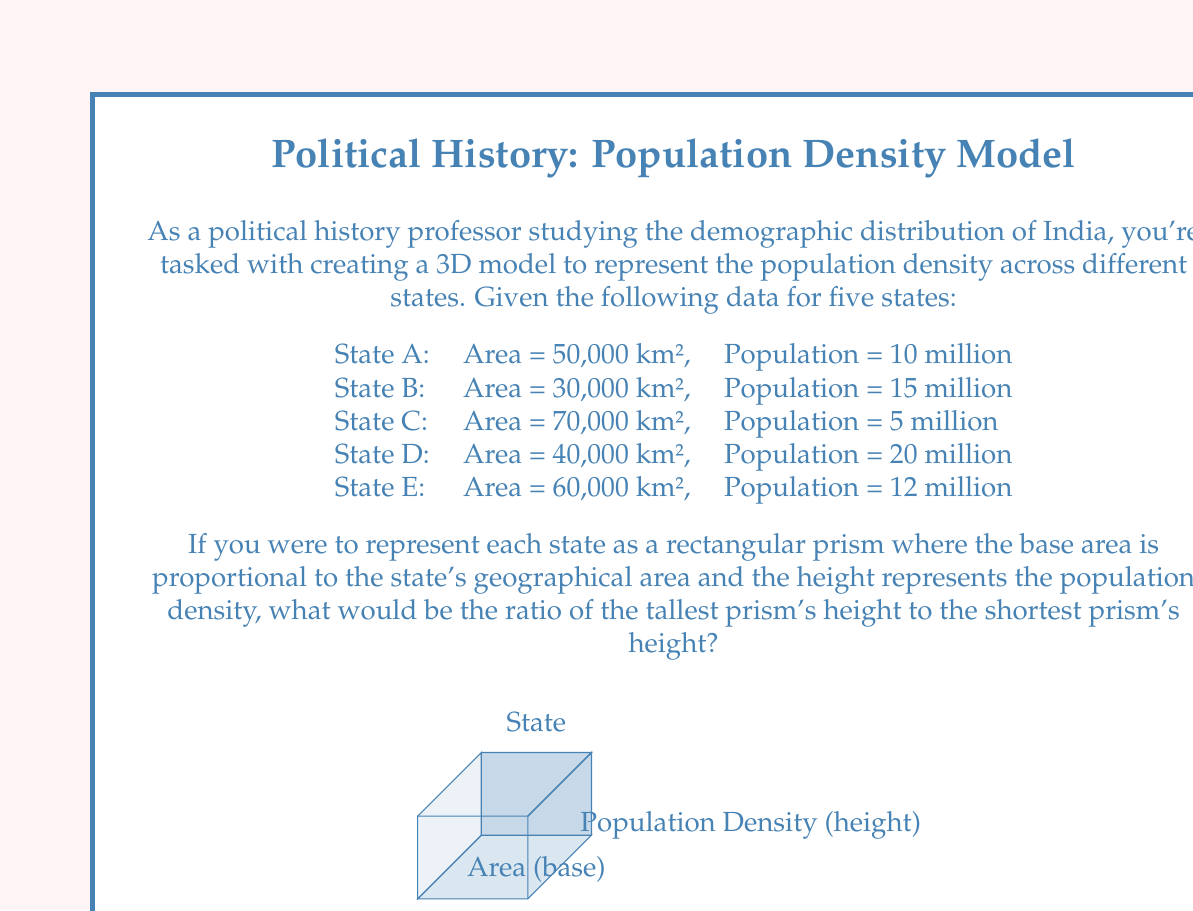Provide a solution to this math problem. To solve this problem, we need to follow these steps:

1) Calculate the population density for each state using the formula:
   $$ \text{Population Density} = \frac{\text{Population}}{\text{Area}} $$

2) For each state:
   State A: $\frac{10,000,000}{50,000} = 200$ people/km²
   State B: $\frac{15,000,000}{30,000} = 500$ people/km²
   State C: $\frac{5,000,000}{70,000} \approx 71.43$ people/km²
   State D: $\frac{20,000,000}{40,000} = 500$ people/km²
   State E: $\frac{12,000,000}{60,000} = 200$ people/km²

3) Identify the highest and lowest population densities:
   Highest: States B and D with 500 people/km²
   Lowest: State C with approximately 71.43 people/km²

4) Calculate the ratio of the highest to the lowest:
   $$ \text{Ratio} = \frac{\text{Highest Density}}{\text{Lowest Density}} = \frac{500}{71.43} \approx 7 $$

Therefore, the ratio of the tallest prism's height to the shortest prism's height would be approximately 7:1.
Answer: 7:1 